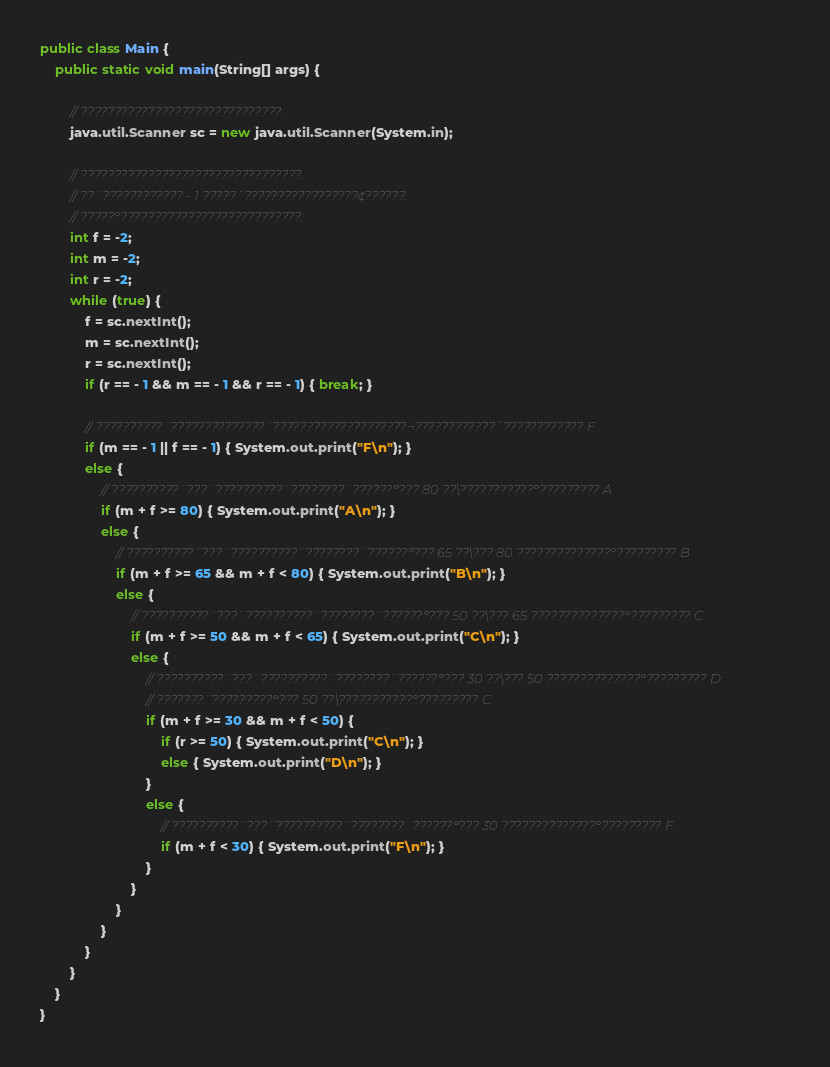<code> <loc_0><loc_0><loc_500><loc_500><_Java_>public class Main {
    public static void main(String[] args) {

        // ??????????????????????????????.
        java.util.Scanner sc = new java.util.Scanner(System.in);

        // ?????????????????????????????????.
        // ??¨???????????? - 1 ?????´?????????????????¢??????.
        // ?????°???????????????????????????.
        int f = -2;
        int m = -2;
        int r = -2;
        while (true) {
            f = sc.nextInt();
            m = sc.nextInt();
            r = sc.nextInt();
            if (r == - 1 && m == - 1 && r == - 1) { break; }

            // ??????????¨??????????????¨????????????????????¬????????????´???????????? F
            if (m == - 1 || f == - 1) { System.out.print("F\n"); }
            else {
                // ??????????¨???¨??????????¨????????¨??????°??? 80 ??\???????????°????????? A
                if (m + f >= 80) { System.out.print("A\n"); }
                else {
                    // ??????????¨???¨??????????¨????????¨??????°??? 65 ??\??? 80 ??????????????°????????? B
                    if (m + f >= 65 && m + f < 80) { System.out.print("B\n"); }
                    else {
                        // ??????????¨???¨??????????¨????????¨??????°??? 50 ??\??? 65 ??????????????°????????? C
                        if (m + f >= 50 && m + f < 65) { System.out.print("C\n"); }
                        else {
                            // ??????????¨???¨??????????¨????????¨??????°??? 30 ??\??? 50 ??????????????°????????? D
                            // ???????¨?????????°??? 50 ??\???????????°????????? C
                            if (m + f >= 30 && m + f < 50) {
                                if (r >= 50) { System.out.print("C\n"); }
                                else { System.out.print("D\n"); }
                            }
                            else {
                                // ??????????¨???¨??????????¨????????¨??????°??? 30 ??????????????°????????? F
                                if (m + f < 30) { System.out.print("F\n"); }
                            }
                        }
                    }
                }
            }
        }
    }
}</code> 